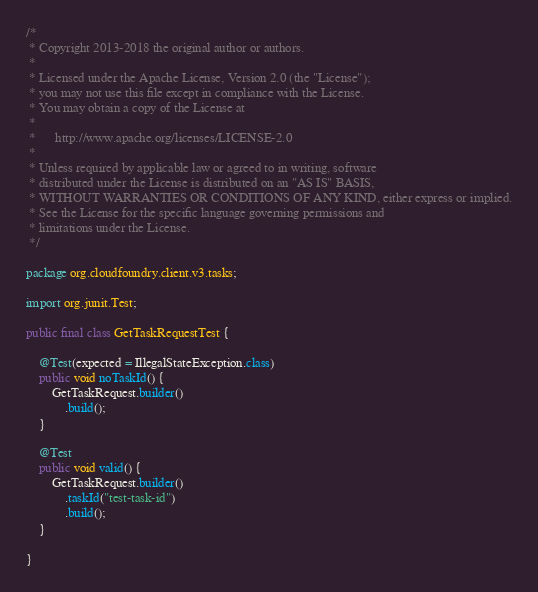<code> <loc_0><loc_0><loc_500><loc_500><_Java_>/*
 * Copyright 2013-2018 the original author or authors.
 *
 * Licensed under the Apache License, Version 2.0 (the "License");
 * you may not use this file except in compliance with the License.
 * You may obtain a copy of the License at
 *
 *      http://www.apache.org/licenses/LICENSE-2.0
 *
 * Unless required by applicable law or agreed to in writing, software
 * distributed under the License is distributed on an "AS IS" BASIS,
 * WITHOUT WARRANTIES OR CONDITIONS OF ANY KIND, either express or implied.
 * See the License for the specific language governing permissions and
 * limitations under the License.
 */

package org.cloudfoundry.client.v3.tasks;

import org.junit.Test;

public final class GetTaskRequestTest {

    @Test(expected = IllegalStateException.class)
    public void noTaskId() {
        GetTaskRequest.builder()
            .build();
    }

    @Test
    public void valid() {
        GetTaskRequest.builder()
            .taskId("test-task-id")
            .build();
    }

}
</code> 